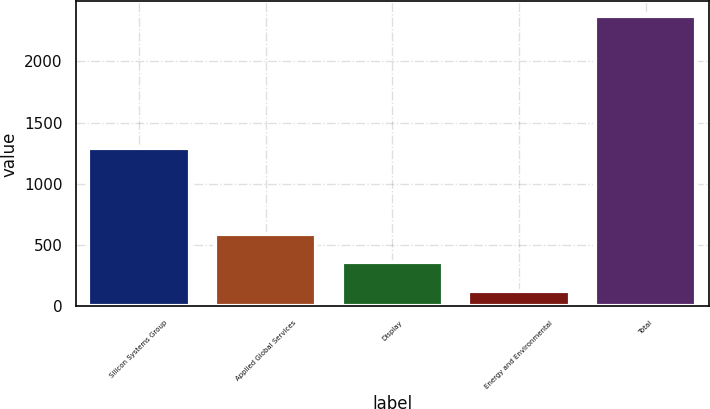Convert chart to OTSL. <chart><loc_0><loc_0><loc_500><loc_500><bar_chart><fcel>Silicon Systems Group<fcel>Applied Global Services<fcel>Display<fcel>Energy and Environmental<fcel>Total<nl><fcel>1295<fcel>591<fcel>361<fcel>125<fcel>2372<nl></chart> 